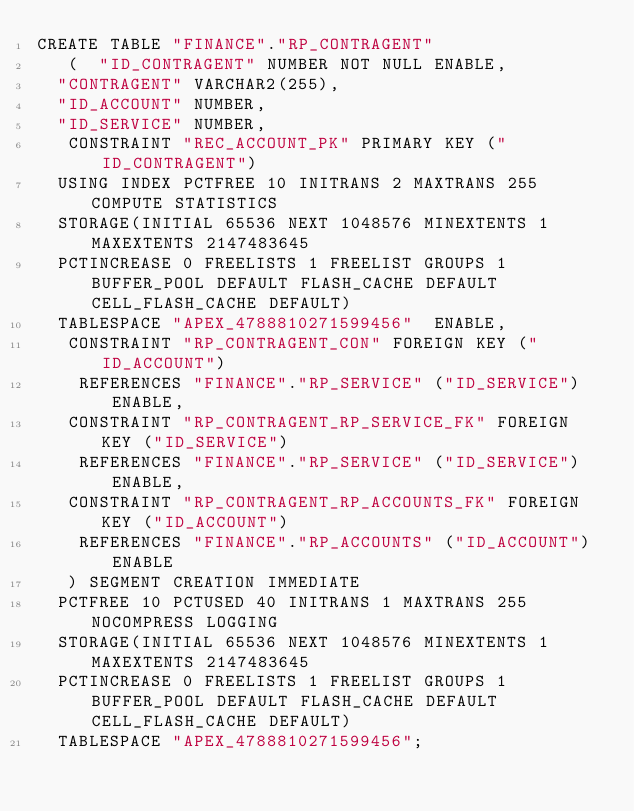<code> <loc_0><loc_0><loc_500><loc_500><_SQL_>CREATE TABLE "FINANCE"."RP_CONTRAGENT" 
   (	"ID_CONTRAGENT" NUMBER NOT NULL ENABLE, 
	"CONTRAGENT" VARCHAR2(255), 
	"ID_ACCOUNT" NUMBER, 
	"ID_SERVICE" NUMBER, 
	 CONSTRAINT "REC_ACCOUNT_PK" PRIMARY KEY ("ID_CONTRAGENT")
  USING INDEX PCTFREE 10 INITRANS 2 MAXTRANS 255 COMPUTE STATISTICS 
  STORAGE(INITIAL 65536 NEXT 1048576 MINEXTENTS 1 MAXEXTENTS 2147483645
  PCTINCREASE 0 FREELISTS 1 FREELIST GROUPS 1 BUFFER_POOL DEFAULT FLASH_CACHE DEFAULT CELL_FLASH_CACHE DEFAULT)
  TABLESPACE "APEX_4788810271599456"  ENABLE, 
	 CONSTRAINT "RP_CONTRAGENT_CON" FOREIGN KEY ("ID_ACCOUNT")
	  REFERENCES "FINANCE"."RP_SERVICE" ("ID_SERVICE") ENABLE, 
	 CONSTRAINT "RP_CONTRAGENT_RP_SERVICE_FK" FOREIGN KEY ("ID_SERVICE")
	  REFERENCES "FINANCE"."RP_SERVICE" ("ID_SERVICE") ENABLE, 
	 CONSTRAINT "RP_CONTRAGENT_RP_ACCOUNTS_FK" FOREIGN KEY ("ID_ACCOUNT")
	  REFERENCES "FINANCE"."RP_ACCOUNTS" ("ID_ACCOUNT") ENABLE
   ) SEGMENT CREATION IMMEDIATE 
  PCTFREE 10 PCTUSED 40 INITRANS 1 MAXTRANS 255 NOCOMPRESS LOGGING
  STORAGE(INITIAL 65536 NEXT 1048576 MINEXTENTS 1 MAXEXTENTS 2147483645
  PCTINCREASE 0 FREELISTS 1 FREELIST GROUPS 1 BUFFER_POOL DEFAULT FLASH_CACHE DEFAULT CELL_FLASH_CACHE DEFAULT)
  TABLESPACE "APEX_4788810271599456";
</code> 